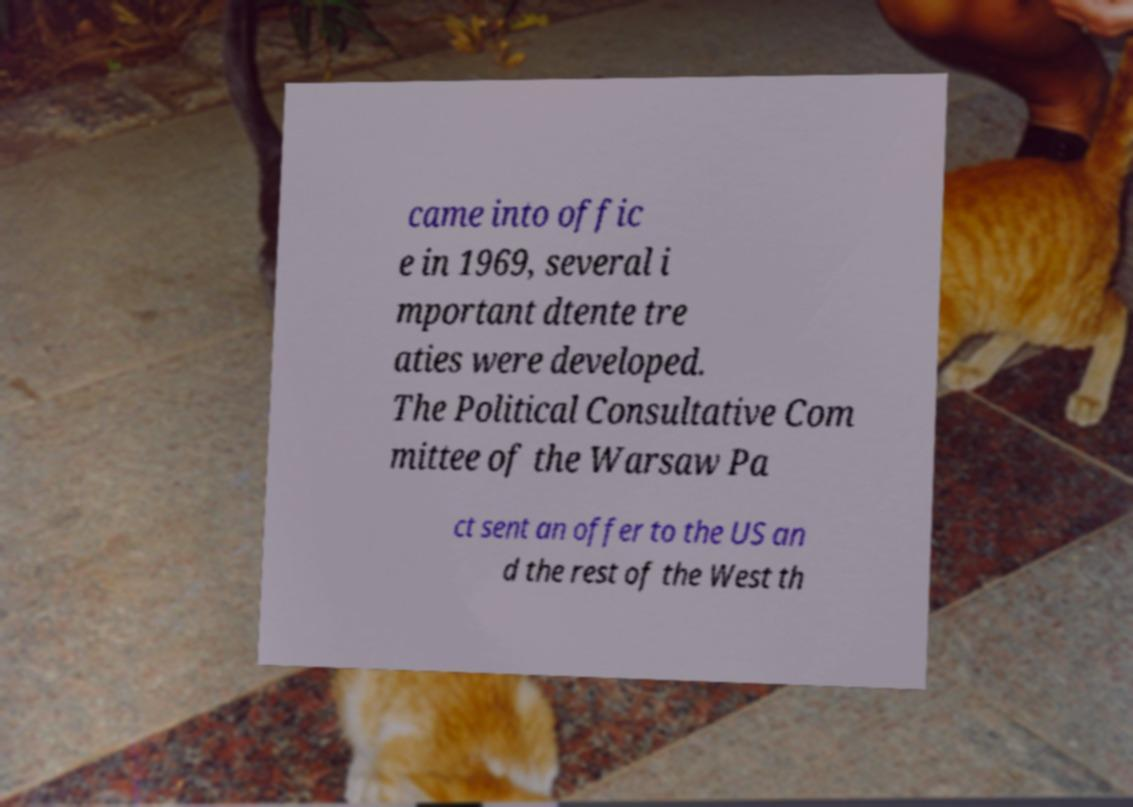I need the written content from this picture converted into text. Can you do that? came into offic e in 1969, several i mportant dtente tre aties were developed. The Political Consultative Com mittee of the Warsaw Pa ct sent an offer to the US an d the rest of the West th 